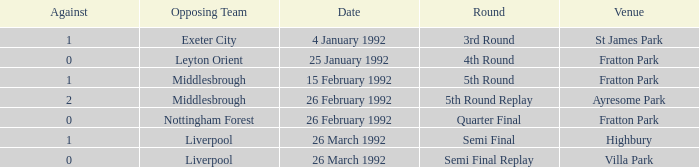Parse the full table. {'header': ['Against', 'Opposing Team', 'Date', 'Round', 'Venue'], 'rows': [['1', 'Exeter City', '4 January 1992', '3rd Round', 'St James Park'], ['0', 'Leyton Orient', '25 January 1992', '4th Round', 'Fratton Park'], ['1', 'Middlesbrough', '15 February 1992', '5th Round', 'Fratton Park'], ['2', 'Middlesbrough', '26 February 1992', '5th Round Replay', 'Ayresome Park'], ['0', 'Nottingham Forest', '26 February 1992', 'Quarter Final', 'Fratton Park'], ['1', 'Liverpool', '26 March 1992', 'Semi Final', 'Highbury'], ['0', 'Liverpool', '26 March 1992', 'Semi Final Replay', 'Villa Park']]} What was the round for Villa Park? Semi Final Replay. 